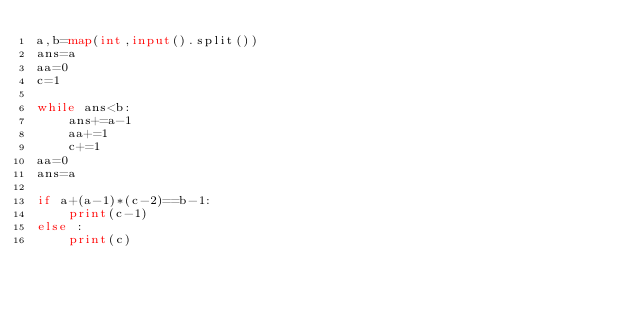Convert code to text. <code><loc_0><loc_0><loc_500><loc_500><_Python_>a,b=map(int,input().split())
ans=a
aa=0
c=1

while ans<b:
    ans+=a-1
    aa+=1
    c+=1
aa=0
ans=a

if a+(a-1)*(c-2)==b-1:
    print(c-1)
else :
    print(c)</code> 